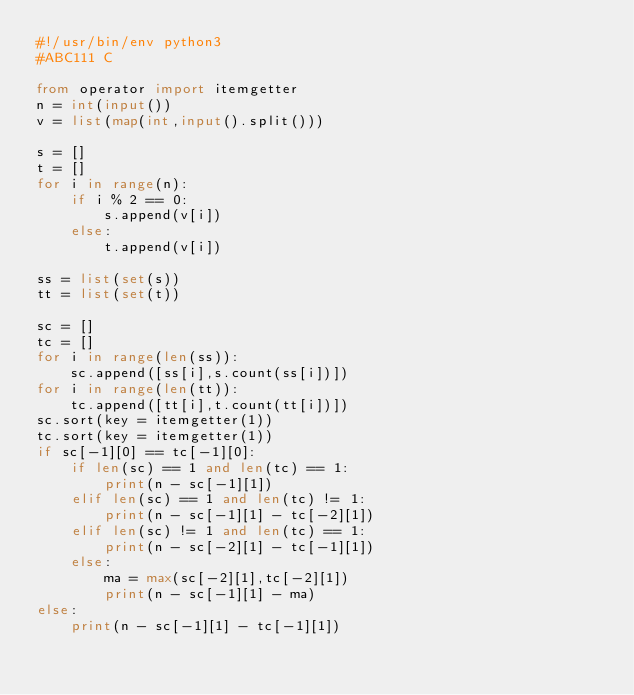Convert code to text. <code><loc_0><loc_0><loc_500><loc_500><_Python_>#!/usr/bin/env python3
#ABC111 C

from operator import itemgetter
n = int(input())
v = list(map(int,input().split()))

s = []
t = []
for i in range(n):
    if i % 2 == 0:
        s.append(v[i])
    else:
        t.append(v[i])

ss = list(set(s))
tt = list(set(t))

sc = []
tc = []
for i in range(len(ss)):
    sc.append([ss[i],s.count(ss[i])])
for i in range(len(tt)):
    tc.append([tt[i],t.count(tt[i])])
sc.sort(key = itemgetter(1))
tc.sort(key = itemgetter(1))
if sc[-1][0] == tc[-1][0]:
    if len(sc) == 1 and len(tc) == 1:
        print(n - sc[-1][1])
    elif len(sc) == 1 and len(tc) != 1:
        print(n - sc[-1][1] - tc[-2][1])
    elif len(sc) != 1 and len(tc) == 1:
        print(n - sc[-2][1] - tc[-1][1])
    else:
        ma = max(sc[-2][1],tc[-2][1])
        print(n - sc[-1][1] - ma)
else:
    print(n - sc[-1][1] - tc[-1][1])
</code> 